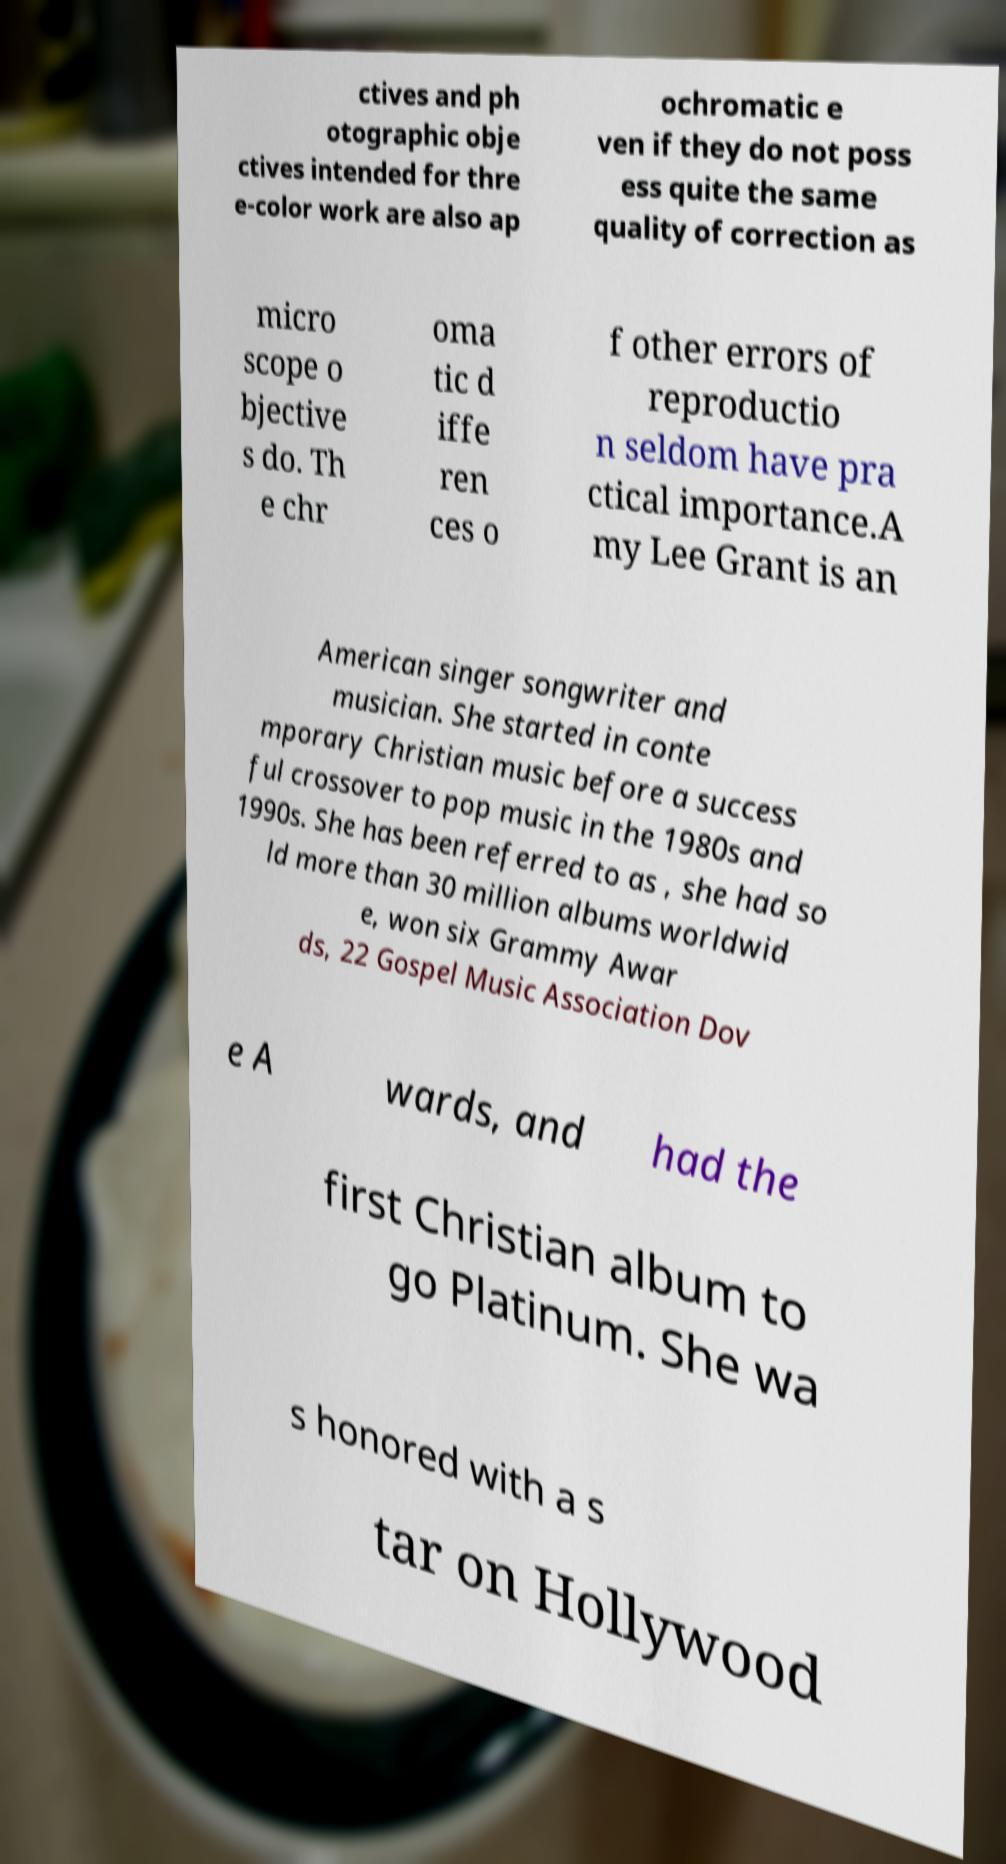Could you assist in decoding the text presented in this image and type it out clearly? ctives and ph otographic obje ctives intended for thre e-color work are also ap ochromatic e ven if they do not poss ess quite the same quality of correction as micro scope o bjective s do. Th e chr oma tic d iffe ren ces o f other errors of reproductio n seldom have pra ctical importance.A my Lee Grant is an American singer songwriter and musician. She started in conte mporary Christian music before a success ful crossover to pop music in the 1980s and 1990s. She has been referred to as , she had so ld more than 30 million albums worldwid e, won six Grammy Awar ds, 22 Gospel Music Association Dov e A wards, and had the first Christian album to go Platinum. She wa s honored with a s tar on Hollywood 